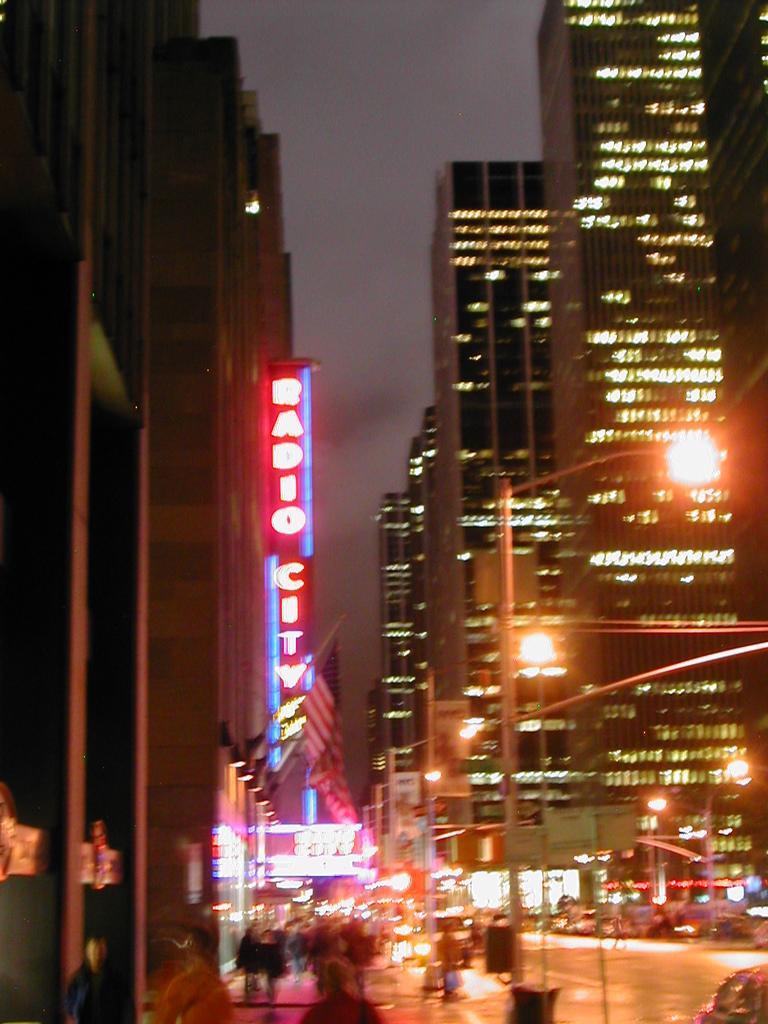Please provide a concise description of this image. This image is taken during night mode. There are many buildings with lightning. Image also consists of light poles. There are also some people walking on the road. Sky and road is also visible. 